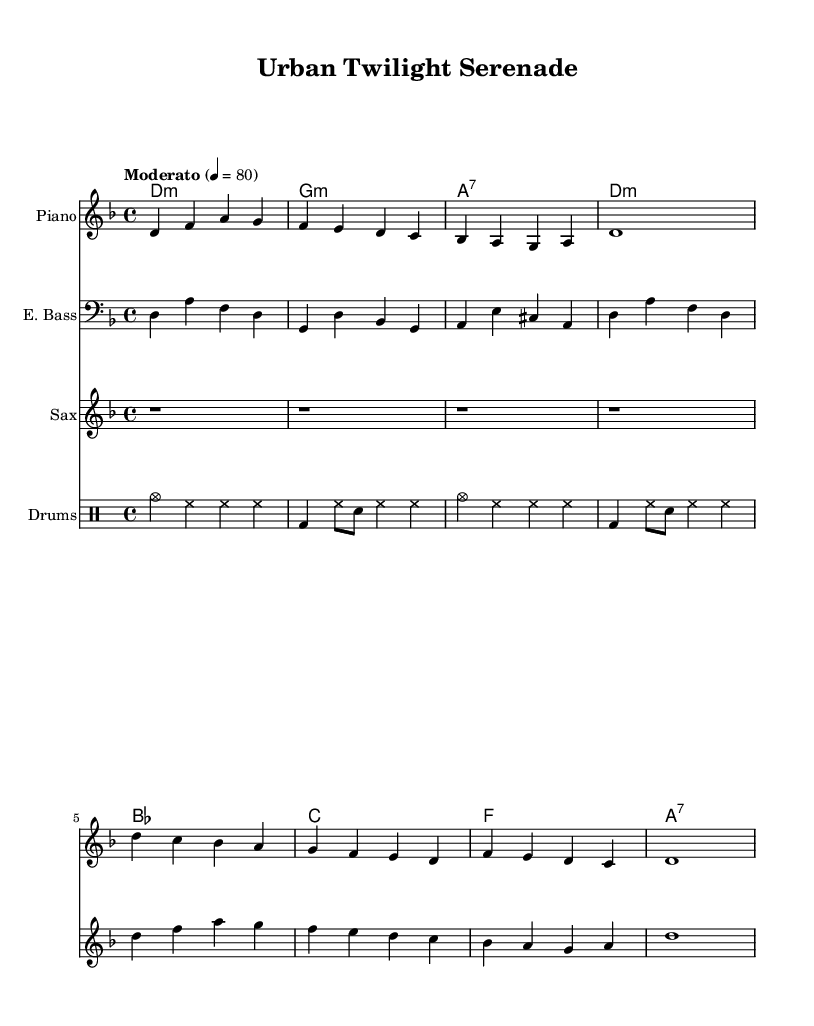What is the key signature of this music? The key signature is D minor, which includes one flat (B flat). This can be determined from the key signature indicated at the beginning of the music.
Answer: D minor What is the time signature of this piece? The time signature is four-four, which shows that there are four beats in each measure. This is indicated just after the key signature at the beginning of the piece.
Answer: Four-four What is the tempo marking given for the composition? The tempo marking is "Moderato," followed by a metronome marking of 80 beats per minute. This is specifically listed in the tempo directive at the start of the piece.
Answer: Moderato, 80 How many measures are there in the melody played by the piano? There are eight measures in the piano melody. This can be counted by looking at the measure lines throughout the music for the piano staff.
Answer: Eight What is the primary instrument featured in this score? The primary instrument featured in the score is the piano, as it is placed first in the list of staff instruments.
Answer: Piano Which chord appears most frequently in the chord progressions? The D minor chord appears most frequently in the chord progression, as it is repeated multiple times at the beginning and throughout the piece.
Answer: D minor What style of music does this piece represent? This piece represents ambient-jazz fusion, characterized by its blending of jazz elements with an atmospheric and ambient sound, intending to evoke a sense of global cityscapes.
Answer: Ambient-jazz fusion 